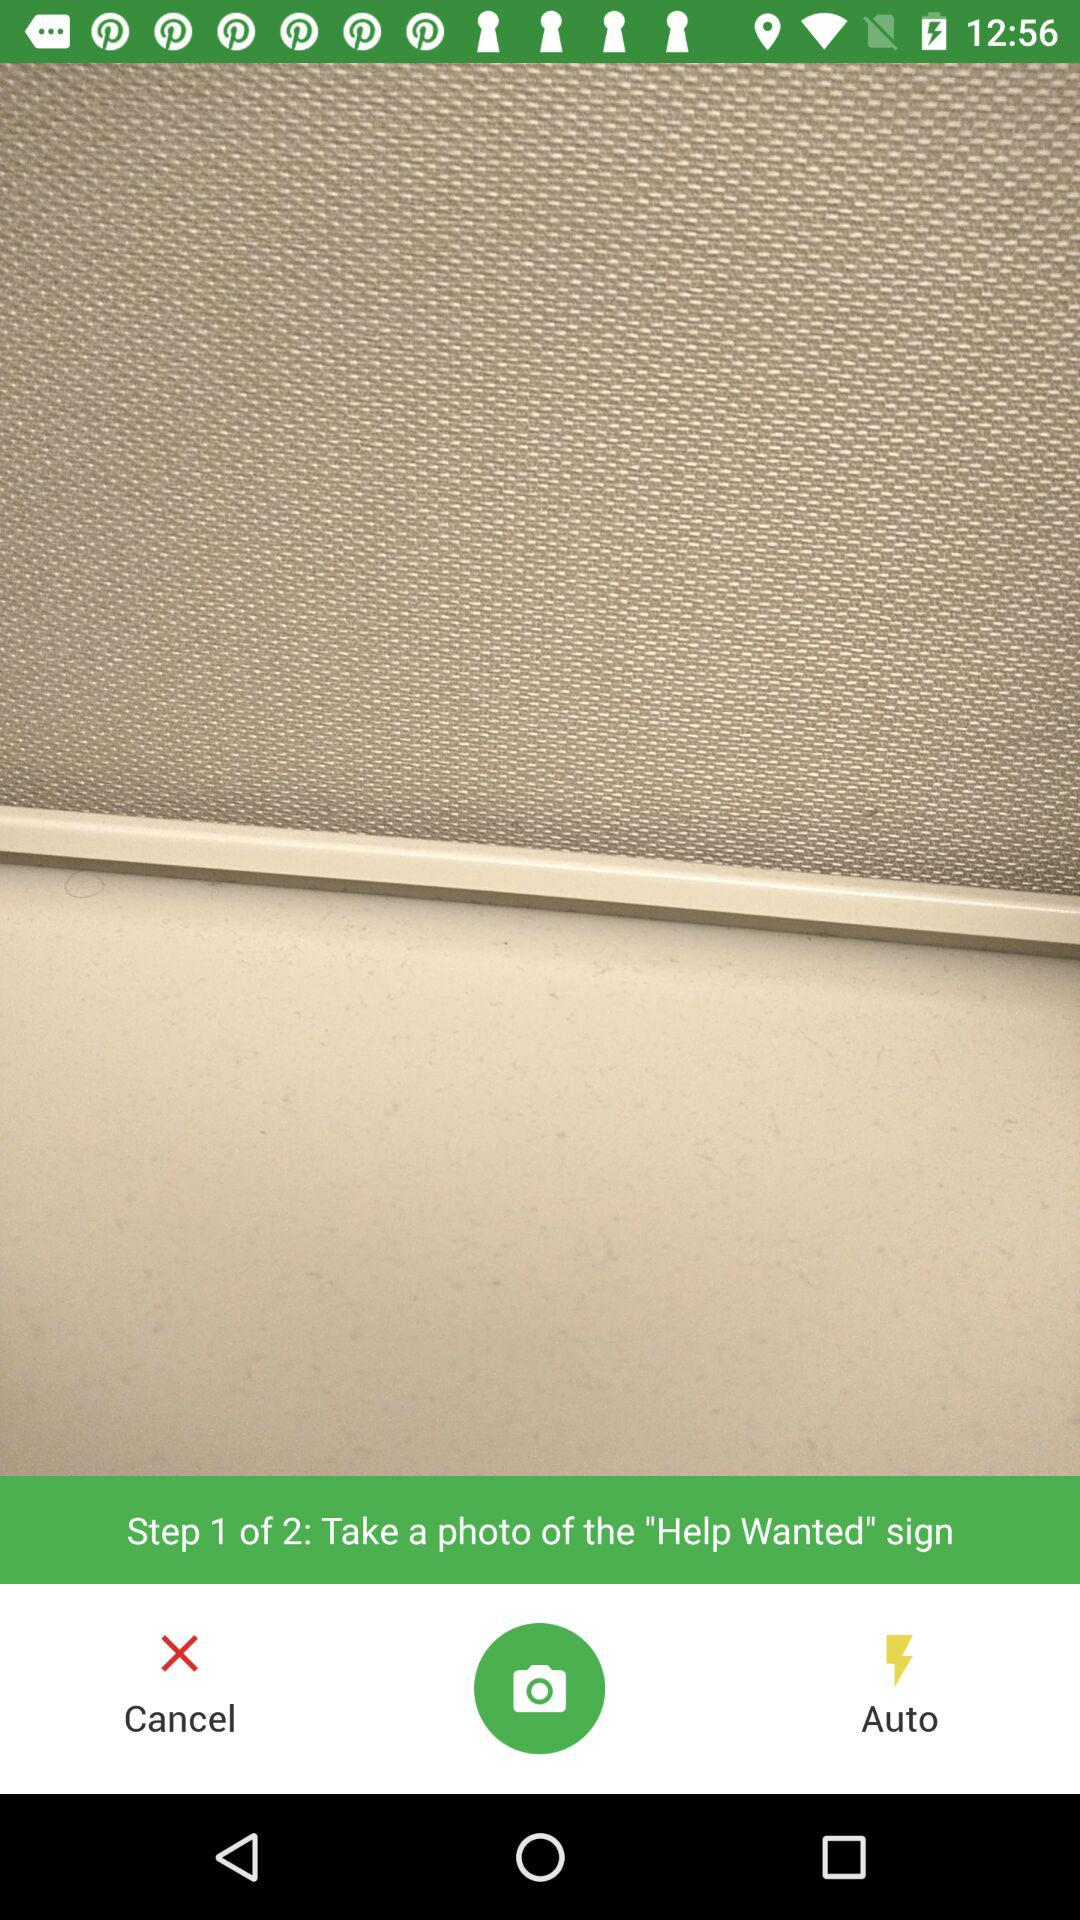How many steps in total are there? There are 2 steps in total. 